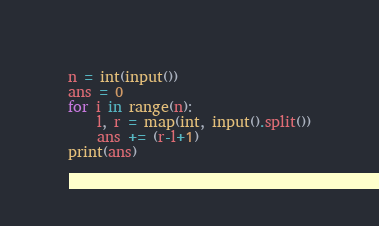<code> <loc_0><loc_0><loc_500><loc_500><_Python_>n = int(input())
ans = 0
for i in range(n):
    l, r = map(int, input().split())
    ans += (r-l+1)
print(ans)</code> 